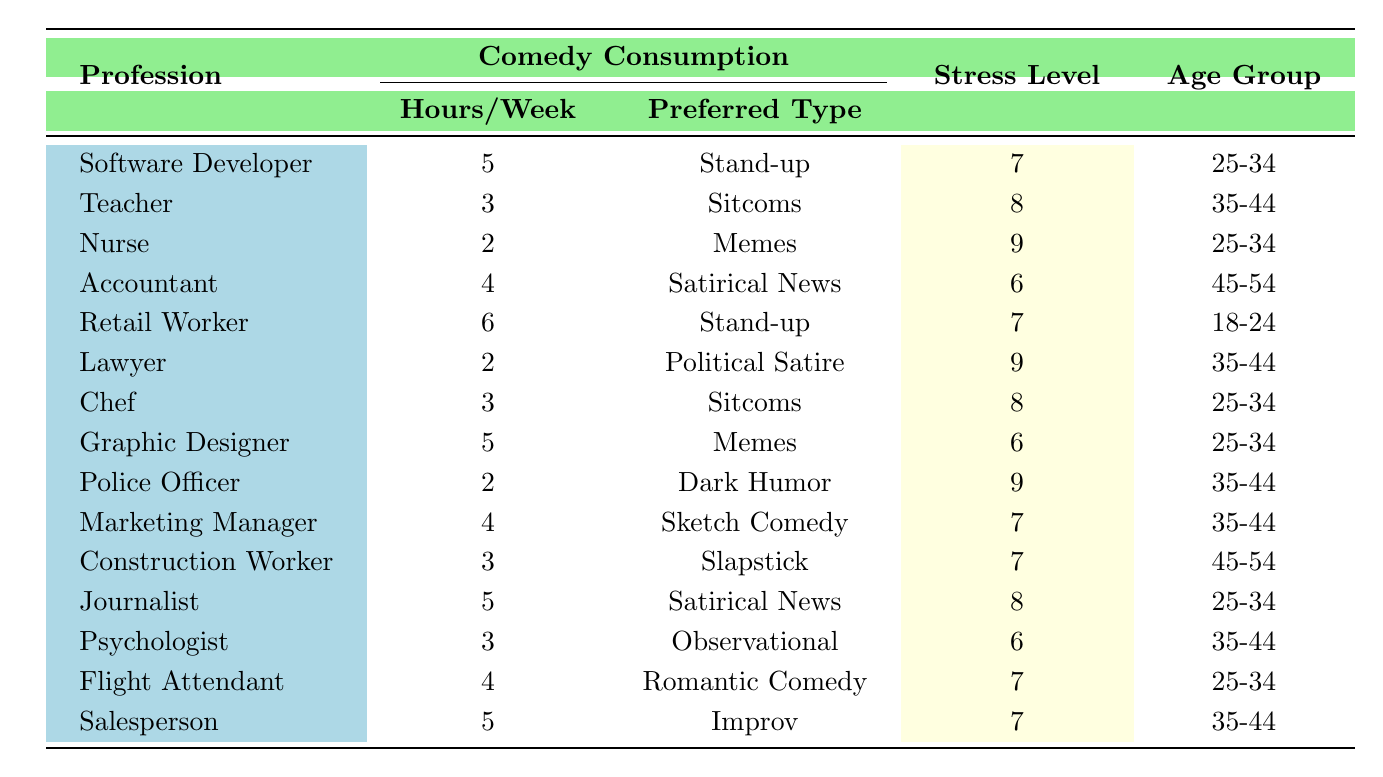What is the stress level for Software Developers? From the table, we can locate the row corresponding to Software Developers, where the Stress Level (1-10) is listed as 7.
Answer: 7 How many hours of comedy do Retail Workers consume per week? In the row for Retail Workers, the column 'Comedy Hours per Week' shows a value of 6.
Answer: 6 What is the preferred type of comedy for Nurses? By checking the row for Nurses, the Preferred Comedy Type is indicated as Memes.
Answer: Memes Which profession shows the highest stress level? Analyzing the 'Stress Level' column, we find that Nurses, Lawyers, and Police Officers each report the highest stress level of 9. Therefore, it appears there are three professions with this highest level.
Answer: Nurses, Lawyers, Police Officers What is the average comedy consumption for professions with a stress level of 8? The relevant professions reporting a stress level of 8 are Teacher, Chef, and Journalist; the corresponding comedy hours are 3, 3, and 5. The total is 11 hours and the average is 11/3 = approximately 3.67.
Answer: 3.67 Do all professions listed in the table consume comedy for more than 4 hours each week? By reviewing the 'Comedy Hours per Week' column, we see that the Nurse, Lawyer, and Chef consume 2 or 3 hours, so the statement is false.
Answer: No What is the most common preferred type of comedy among professions with a stress level of 7? The professions with a stress level of 7 are Software Developer, Retail Worker, Marketing Manager, Construction Worker, Flight Attendant, and Salesperson. The preferred types among these professions are Stand-up, Stand-up, Sketch Comedy, Slapstick, Romantic Comedy, and Improv. The most common type here is Stand-up, found in two different professions.
Answer: Stand-up What is the total comedy consumption of Police Officers and Nurses combined? By referring to their respective rows, Police Officers have 2 hours and Nurses have 2 hours, totalizing 2 + 2 = 4 hours of comedy consumption overall.
Answer: 4 Which age group has the most professions listed in this table? By reviewing the 'Age Group' column and counting occurrences: 18-24 (1), 25-34 (4), 35-44 (5), and 45-54 (2). The most common age group is 35-44 with 5 professions.
Answer: 35-44 